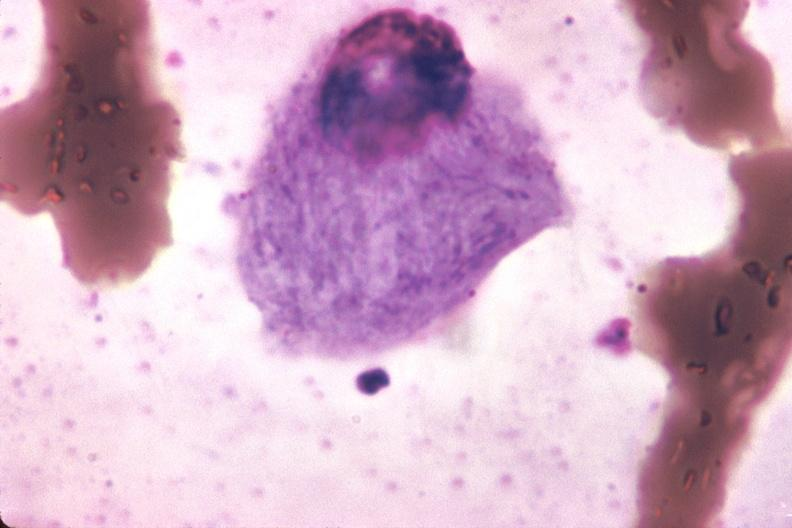s polysplenia present?
Answer the question using a single word or phrase. No 